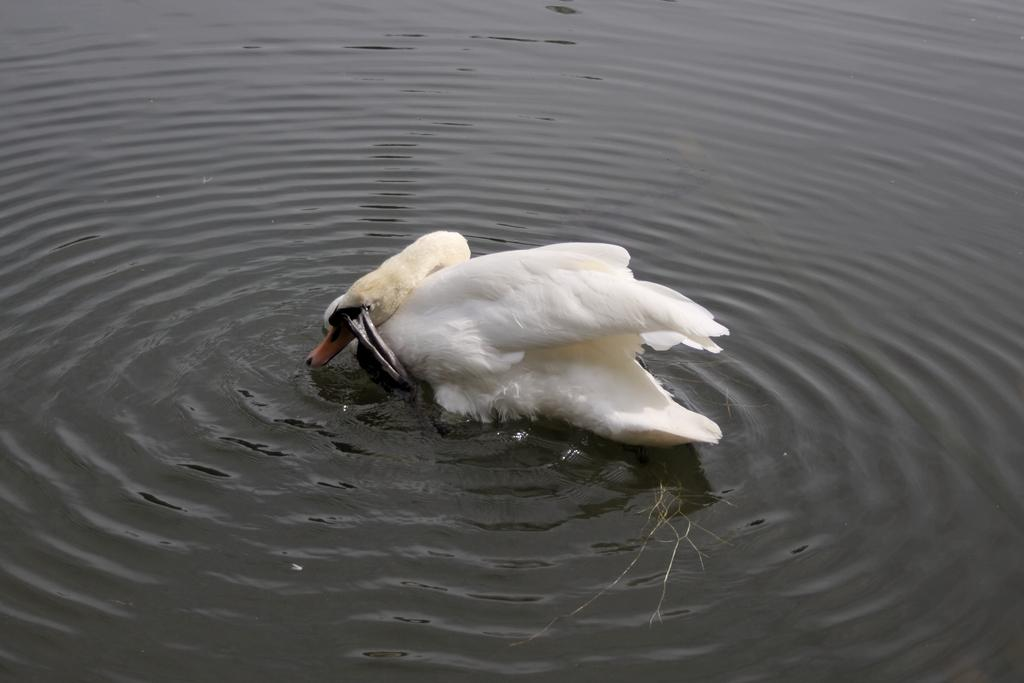What is the primary element in the image? There is water in the image. Are there any animals present in the water? Yes, there are two white swans in the water. What type of structure can be seen in the water with the swans? There is no structure present in the water with the swans in the image. 